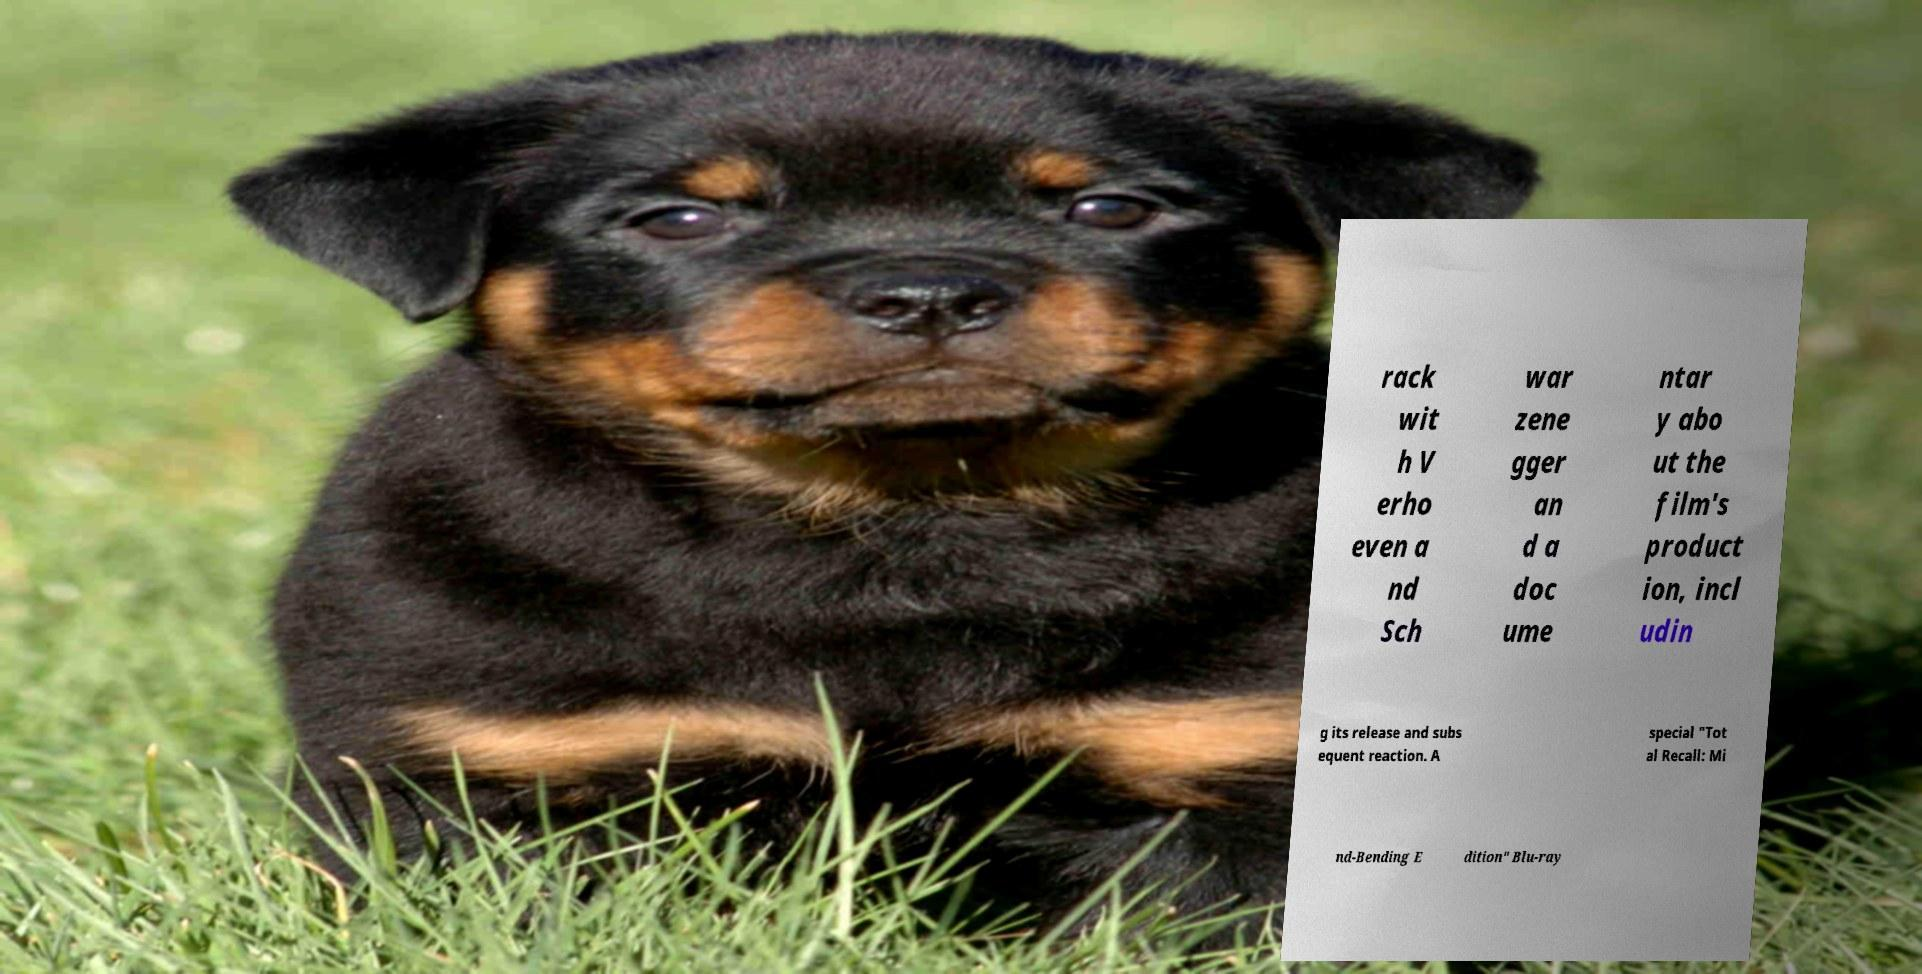Please read and relay the text visible in this image. What does it say? rack wit h V erho even a nd Sch war zene gger an d a doc ume ntar y abo ut the film's product ion, incl udin g its release and subs equent reaction. A special "Tot al Recall: Mi nd-Bending E dition" Blu-ray 